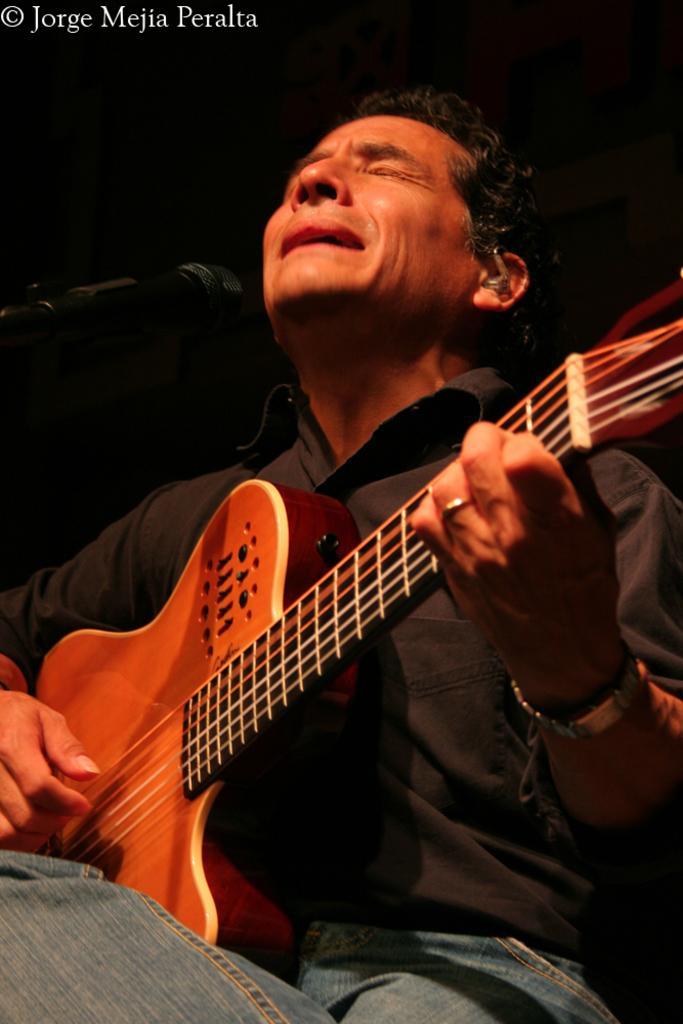Could you give a brief overview of what you see in this image? I can see in this image a man is playing a guitar in front of a microphone. The man is wearing black shirt and jeans. 